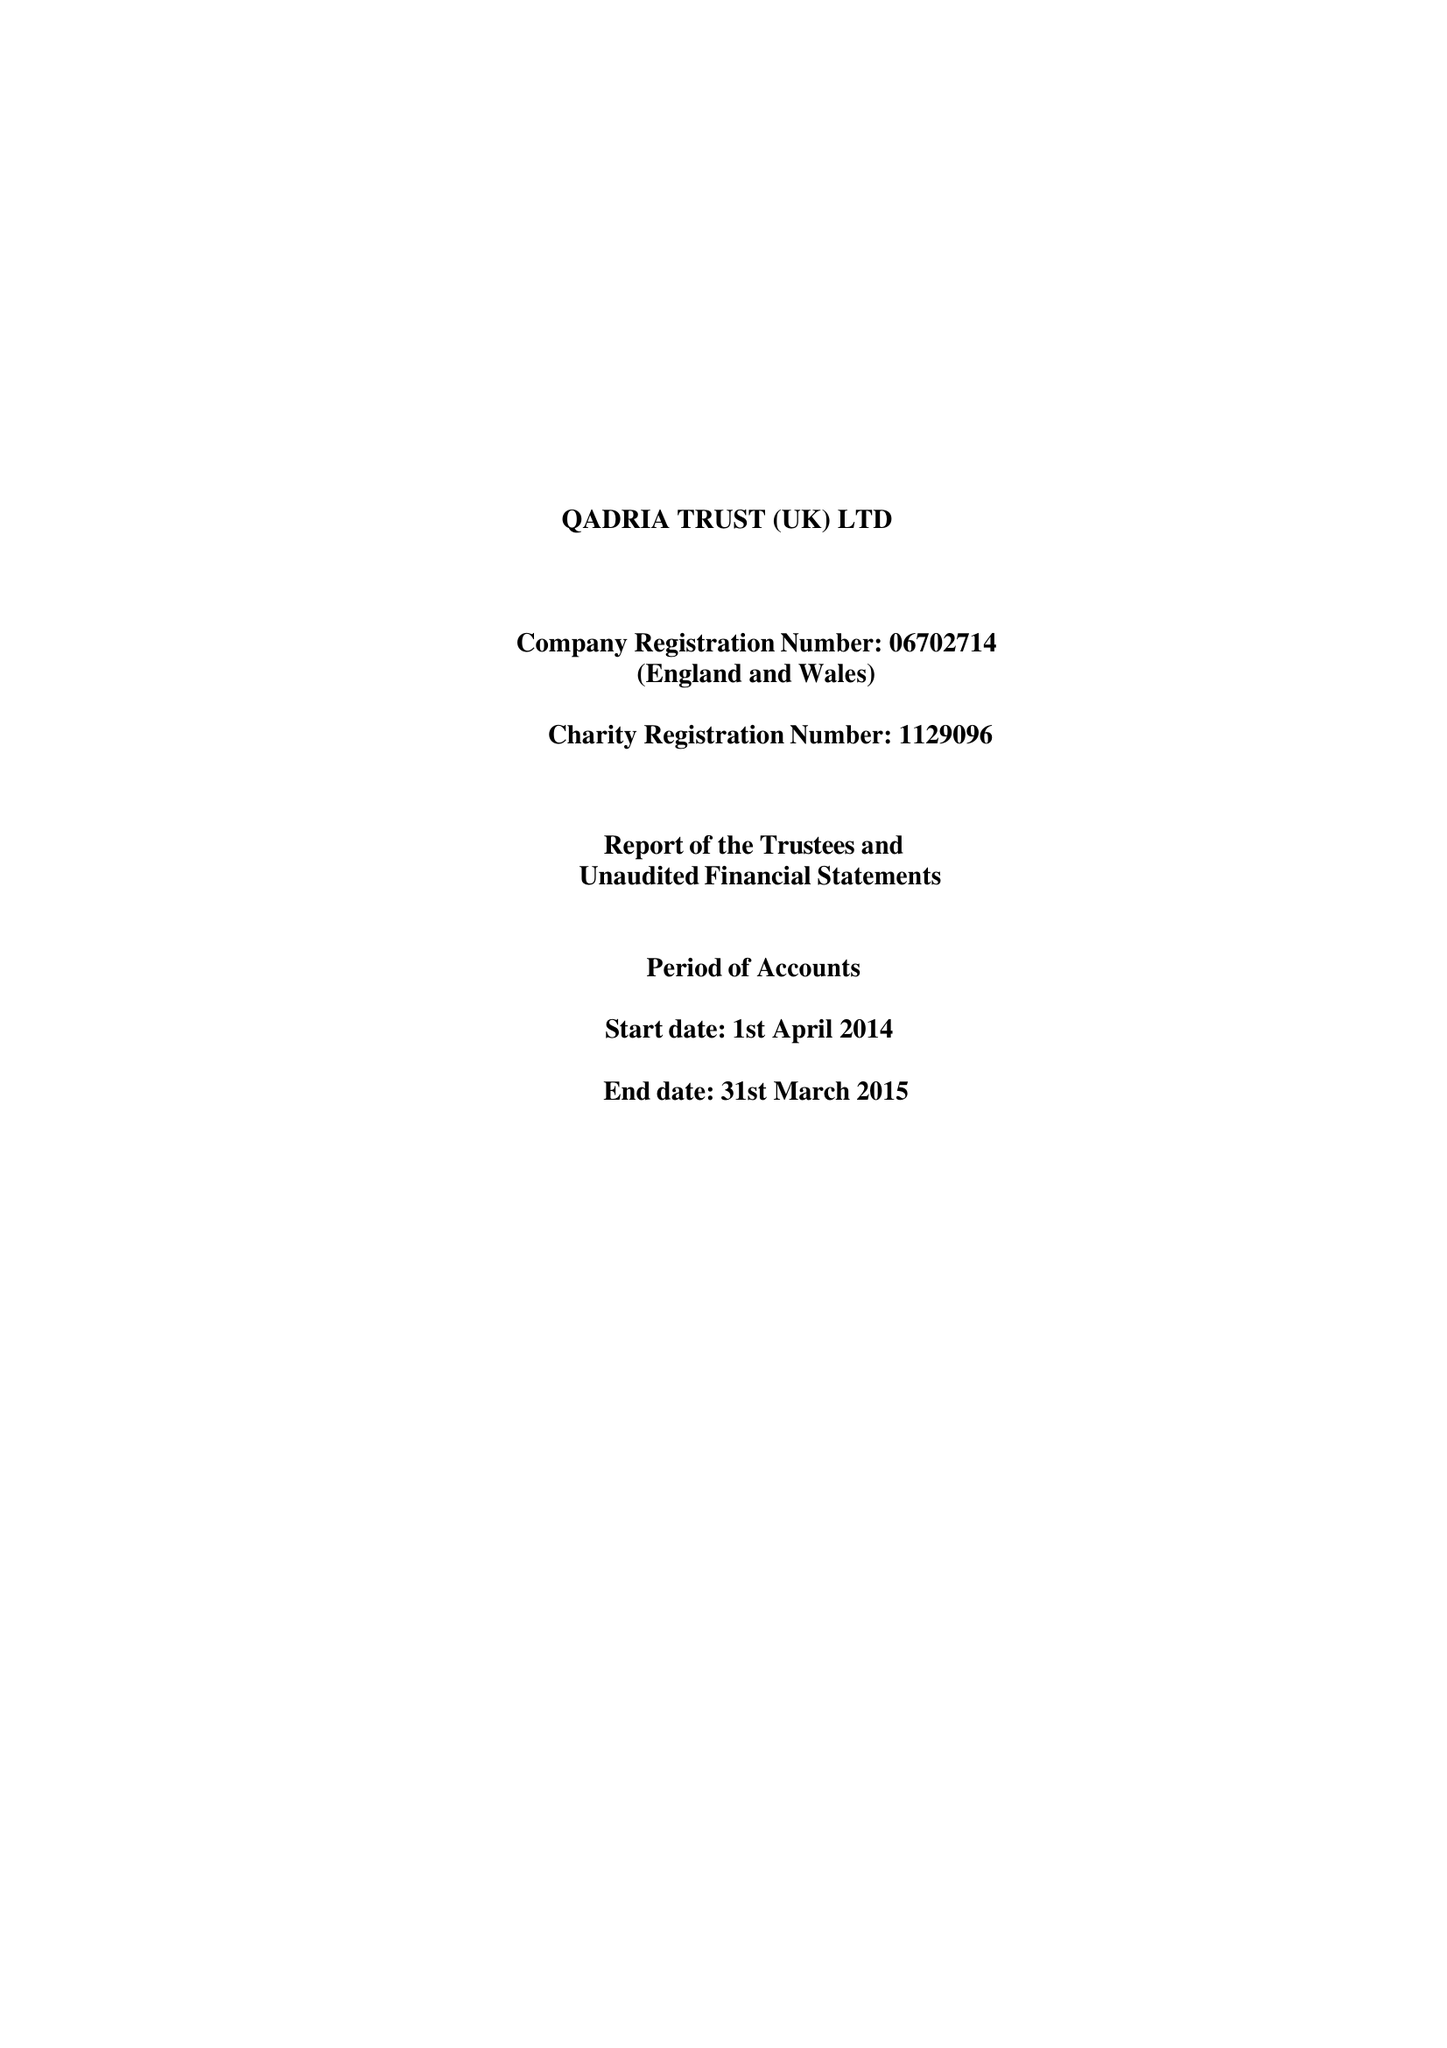What is the value for the address__post_town?
Answer the question using a single word or phrase. BIRMINGHAM 